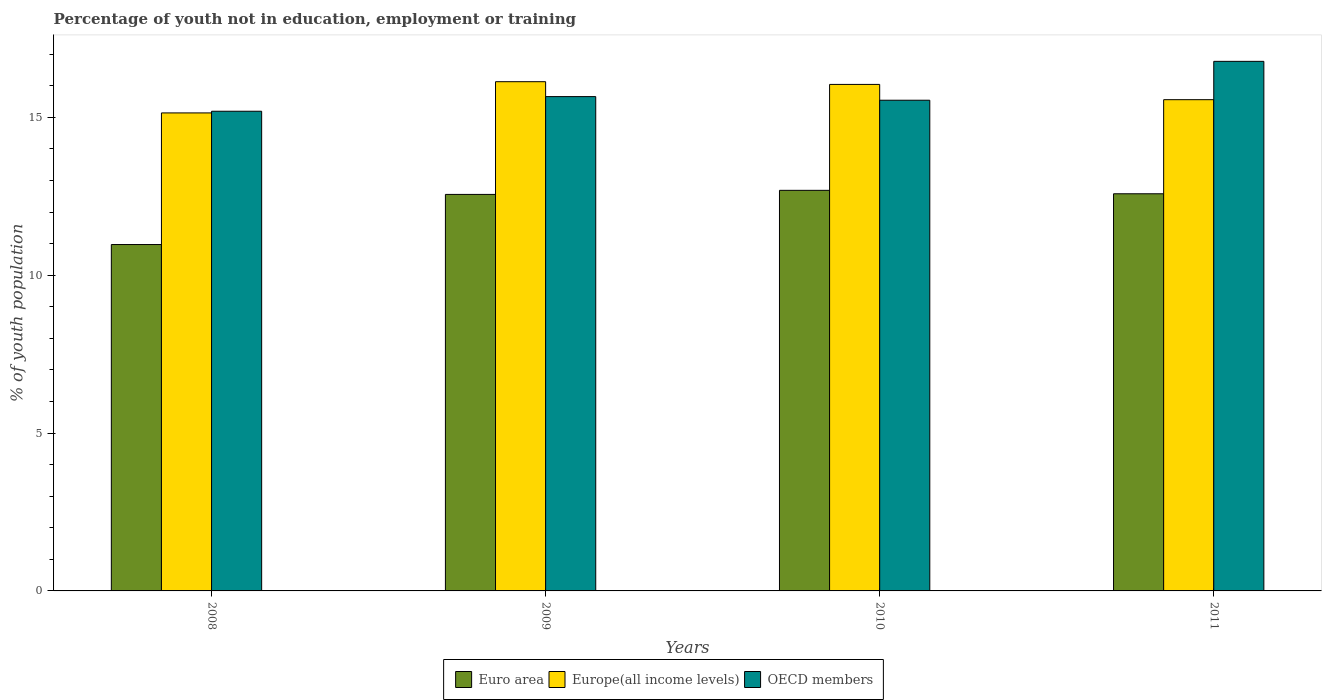How many different coloured bars are there?
Provide a short and direct response. 3. How many groups of bars are there?
Offer a terse response. 4. How many bars are there on the 4th tick from the right?
Provide a short and direct response. 3. What is the percentage of unemployed youth population in in Euro area in 2008?
Offer a very short reply. 10.97. Across all years, what is the maximum percentage of unemployed youth population in in Europe(all income levels)?
Ensure brevity in your answer.  16.13. Across all years, what is the minimum percentage of unemployed youth population in in OECD members?
Your answer should be compact. 15.19. In which year was the percentage of unemployed youth population in in Europe(all income levels) maximum?
Offer a terse response. 2009. What is the total percentage of unemployed youth population in in OECD members in the graph?
Your response must be concise. 63.16. What is the difference between the percentage of unemployed youth population in in Euro area in 2008 and that in 2009?
Provide a succinct answer. -1.59. What is the difference between the percentage of unemployed youth population in in OECD members in 2008 and the percentage of unemployed youth population in in Euro area in 2009?
Your answer should be very brief. 2.63. What is the average percentage of unemployed youth population in in Europe(all income levels) per year?
Your answer should be very brief. 15.72. In the year 2011, what is the difference between the percentage of unemployed youth population in in Euro area and percentage of unemployed youth population in in OECD members?
Your answer should be compact. -4.19. What is the ratio of the percentage of unemployed youth population in in OECD members in 2008 to that in 2009?
Give a very brief answer. 0.97. Is the percentage of unemployed youth population in in Euro area in 2008 less than that in 2009?
Your response must be concise. Yes. Is the difference between the percentage of unemployed youth population in in Euro area in 2008 and 2009 greater than the difference between the percentage of unemployed youth population in in OECD members in 2008 and 2009?
Keep it short and to the point. No. What is the difference between the highest and the second highest percentage of unemployed youth population in in Europe(all income levels)?
Offer a terse response. 0.09. What is the difference between the highest and the lowest percentage of unemployed youth population in in Euro area?
Provide a succinct answer. 1.72. What does the 2nd bar from the right in 2008 represents?
Your response must be concise. Europe(all income levels). How many bars are there?
Give a very brief answer. 12. What is the difference between two consecutive major ticks on the Y-axis?
Your answer should be very brief. 5. Does the graph contain any zero values?
Ensure brevity in your answer.  No. Does the graph contain grids?
Make the answer very short. No. What is the title of the graph?
Provide a succinct answer. Percentage of youth not in education, employment or training. What is the label or title of the Y-axis?
Your answer should be compact. % of youth population. What is the % of youth population in Euro area in 2008?
Offer a very short reply. 10.97. What is the % of youth population in Europe(all income levels) in 2008?
Offer a terse response. 15.14. What is the % of youth population in OECD members in 2008?
Give a very brief answer. 15.19. What is the % of youth population in Euro area in 2009?
Provide a succinct answer. 12.56. What is the % of youth population in Europe(all income levels) in 2009?
Offer a terse response. 16.13. What is the % of youth population of OECD members in 2009?
Make the answer very short. 15.66. What is the % of youth population in Euro area in 2010?
Make the answer very short. 12.69. What is the % of youth population of Europe(all income levels) in 2010?
Provide a succinct answer. 16.04. What is the % of youth population in OECD members in 2010?
Give a very brief answer. 15.54. What is the % of youth population in Euro area in 2011?
Offer a terse response. 12.58. What is the % of youth population in Europe(all income levels) in 2011?
Provide a short and direct response. 15.56. What is the % of youth population of OECD members in 2011?
Make the answer very short. 16.77. Across all years, what is the maximum % of youth population in Euro area?
Keep it short and to the point. 12.69. Across all years, what is the maximum % of youth population of Europe(all income levels)?
Offer a terse response. 16.13. Across all years, what is the maximum % of youth population of OECD members?
Offer a terse response. 16.77. Across all years, what is the minimum % of youth population of Euro area?
Offer a terse response. 10.97. Across all years, what is the minimum % of youth population of Europe(all income levels)?
Offer a very short reply. 15.14. Across all years, what is the minimum % of youth population in OECD members?
Keep it short and to the point. 15.19. What is the total % of youth population of Euro area in the graph?
Your answer should be very brief. 48.79. What is the total % of youth population in Europe(all income levels) in the graph?
Provide a short and direct response. 62.87. What is the total % of youth population in OECD members in the graph?
Keep it short and to the point. 63.16. What is the difference between the % of youth population of Euro area in 2008 and that in 2009?
Offer a very short reply. -1.59. What is the difference between the % of youth population in Europe(all income levels) in 2008 and that in 2009?
Offer a very short reply. -0.99. What is the difference between the % of youth population of OECD members in 2008 and that in 2009?
Make the answer very short. -0.46. What is the difference between the % of youth population of Euro area in 2008 and that in 2010?
Your answer should be very brief. -1.72. What is the difference between the % of youth population of Europe(all income levels) in 2008 and that in 2010?
Ensure brevity in your answer.  -0.9. What is the difference between the % of youth population of OECD members in 2008 and that in 2010?
Offer a terse response. -0.35. What is the difference between the % of youth population of Euro area in 2008 and that in 2011?
Keep it short and to the point. -1.61. What is the difference between the % of youth population of Europe(all income levels) in 2008 and that in 2011?
Offer a very short reply. -0.42. What is the difference between the % of youth population in OECD members in 2008 and that in 2011?
Your answer should be compact. -1.58. What is the difference between the % of youth population of Euro area in 2009 and that in 2010?
Your answer should be compact. -0.13. What is the difference between the % of youth population in Europe(all income levels) in 2009 and that in 2010?
Provide a short and direct response. 0.09. What is the difference between the % of youth population of OECD members in 2009 and that in 2010?
Offer a terse response. 0.12. What is the difference between the % of youth population in Euro area in 2009 and that in 2011?
Make the answer very short. -0.02. What is the difference between the % of youth population of Europe(all income levels) in 2009 and that in 2011?
Offer a terse response. 0.57. What is the difference between the % of youth population in OECD members in 2009 and that in 2011?
Offer a terse response. -1.12. What is the difference between the % of youth population in Euro area in 2010 and that in 2011?
Keep it short and to the point. 0.11. What is the difference between the % of youth population in Europe(all income levels) in 2010 and that in 2011?
Give a very brief answer. 0.48. What is the difference between the % of youth population of OECD members in 2010 and that in 2011?
Your response must be concise. -1.23. What is the difference between the % of youth population in Euro area in 2008 and the % of youth population in Europe(all income levels) in 2009?
Ensure brevity in your answer.  -5.16. What is the difference between the % of youth population of Euro area in 2008 and the % of youth population of OECD members in 2009?
Make the answer very short. -4.69. What is the difference between the % of youth population of Europe(all income levels) in 2008 and the % of youth population of OECD members in 2009?
Offer a terse response. -0.52. What is the difference between the % of youth population of Euro area in 2008 and the % of youth population of Europe(all income levels) in 2010?
Keep it short and to the point. -5.07. What is the difference between the % of youth population of Euro area in 2008 and the % of youth population of OECD members in 2010?
Offer a very short reply. -4.57. What is the difference between the % of youth population in Europe(all income levels) in 2008 and the % of youth population in OECD members in 2010?
Your answer should be very brief. -0.4. What is the difference between the % of youth population of Euro area in 2008 and the % of youth population of Europe(all income levels) in 2011?
Provide a succinct answer. -4.59. What is the difference between the % of youth population in Euro area in 2008 and the % of youth population in OECD members in 2011?
Your answer should be compact. -5.8. What is the difference between the % of youth population of Europe(all income levels) in 2008 and the % of youth population of OECD members in 2011?
Ensure brevity in your answer.  -1.63. What is the difference between the % of youth population of Euro area in 2009 and the % of youth population of Europe(all income levels) in 2010?
Give a very brief answer. -3.48. What is the difference between the % of youth population in Euro area in 2009 and the % of youth population in OECD members in 2010?
Provide a short and direct response. -2.98. What is the difference between the % of youth population of Europe(all income levels) in 2009 and the % of youth population of OECD members in 2010?
Make the answer very short. 0.59. What is the difference between the % of youth population of Euro area in 2009 and the % of youth population of Europe(all income levels) in 2011?
Your answer should be compact. -3. What is the difference between the % of youth population in Euro area in 2009 and the % of youth population in OECD members in 2011?
Your response must be concise. -4.21. What is the difference between the % of youth population of Europe(all income levels) in 2009 and the % of youth population of OECD members in 2011?
Give a very brief answer. -0.64. What is the difference between the % of youth population of Euro area in 2010 and the % of youth population of Europe(all income levels) in 2011?
Provide a short and direct response. -2.87. What is the difference between the % of youth population of Euro area in 2010 and the % of youth population of OECD members in 2011?
Provide a short and direct response. -4.08. What is the difference between the % of youth population of Europe(all income levels) in 2010 and the % of youth population of OECD members in 2011?
Give a very brief answer. -0.73. What is the average % of youth population in Euro area per year?
Your response must be concise. 12.2. What is the average % of youth population in Europe(all income levels) per year?
Your answer should be very brief. 15.72. What is the average % of youth population of OECD members per year?
Your answer should be compact. 15.79. In the year 2008, what is the difference between the % of youth population of Euro area and % of youth population of Europe(all income levels)?
Keep it short and to the point. -4.17. In the year 2008, what is the difference between the % of youth population in Euro area and % of youth population in OECD members?
Your response must be concise. -4.22. In the year 2008, what is the difference between the % of youth population of Europe(all income levels) and % of youth population of OECD members?
Your answer should be very brief. -0.05. In the year 2009, what is the difference between the % of youth population in Euro area and % of youth population in Europe(all income levels)?
Offer a terse response. -3.57. In the year 2009, what is the difference between the % of youth population of Euro area and % of youth population of OECD members?
Your answer should be compact. -3.1. In the year 2009, what is the difference between the % of youth population in Europe(all income levels) and % of youth population in OECD members?
Your answer should be very brief. 0.47. In the year 2010, what is the difference between the % of youth population in Euro area and % of youth population in Europe(all income levels)?
Your answer should be compact. -3.35. In the year 2010, what is the difference between the % of youth population of Euro area and % of youth population of OECD members?
Give a very brief answer. -2.85. In the year 2010, what is the difference between the % of youth population of Europe(all income levels) and % of youth population of OECD members?
Give a very brief answer. 0.5. In the year 2011, what is the difference between the % of youth population in Euro area and % of youth population in Europe(all income levels)?
Give a very brief answer. -2.98. In the year 2011, what is the difference between the % of youth population in Euro area and % of youth population in OECD members?
Give a very brief answer. -4.19. In the year 2011, what is the difference between the % of youth population in Europe(all income levels) and % of youth population in OECD members?
Provide a short and direct response. -1.21. What is the ratio of the % of youth population of Euro area in 2008 to that in 2009?
Your answer should be compact. 0.87. What is the ratio of the % of youth population of Europe(all income levels) in 2008 to that in 2009?
Offer a terse response. 0.94. What is the ratio of the % of youth population of OECD members in 2008 to that in 2009?
Offer a terse response. 0.97. What is the ratio of the % of youth population in Euro area in 2008 to that in 2010?
Keep it short and to the point. 0.86. What is the ratio of the % of youth population of Europe(all income levels) in 2008 to that in 2010?
Make the answer very short. 0.94. What is the ratio of the % of youth population in OECD members in 2008 to that in 2010?
Make the answer very short. 0.98. What is the ratio of the % of youth population in Euro area in 2008 to that in 2011?
Your answer should be very brief. 0.87. What is the ratio of the % of youth population in OECD members in 2008 to that in 2011?
Keep it short and to the point. 0.91. What is the ratio of the % of youth population in OECD members in 2009 to that in 2010?
Ensure brevity in your answer.  1.01. What is the ratio of the % of youth population in Europe(all income levels) in 2009 to that in 2011?
Ensure brevity in your answer.  1.04. What is the ratio of the % of youth population of OECD members in 2009 to that in 2011?
Offer a very short reply. 0.93. What is the ratio of the % of youth population in Euro area in 2010 to that in 2011?
Provide a succinct answer. 1.01. What is the ratio of the % of youth population of Europe(all income levels) in 2010 to that in 2011?
Provide a short and direct response. 1.03. What is the ratio of the % of youth population of OECD members in 2010 to that in 2011?
Your response must be concise. 0.93. What is the difference between the highest and the second highest % of youth population of Euro area?
Your answer should be very brief. 0.11. What is the difference between the highest and the second highest % of youth population in Europe(all income levels)?
Make the answer very short. 0.09. What is the difference between the highest and the second highest % of youth population in OECD members?
Make the answer very short. 1.12. What is the difference between the highest and the lowest % of youth population of Euro area?
Make the answer very short. 1.72. What is the difference between the highest and the lowest % of youth population in OECD members?
Keep it short and to the point. 1.58. 